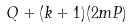Convert formula to latex. <formula><loc_0><loc_0><loc_500><loc_500>Q + ( k + 1 ) ( 2 m P )</formula> 